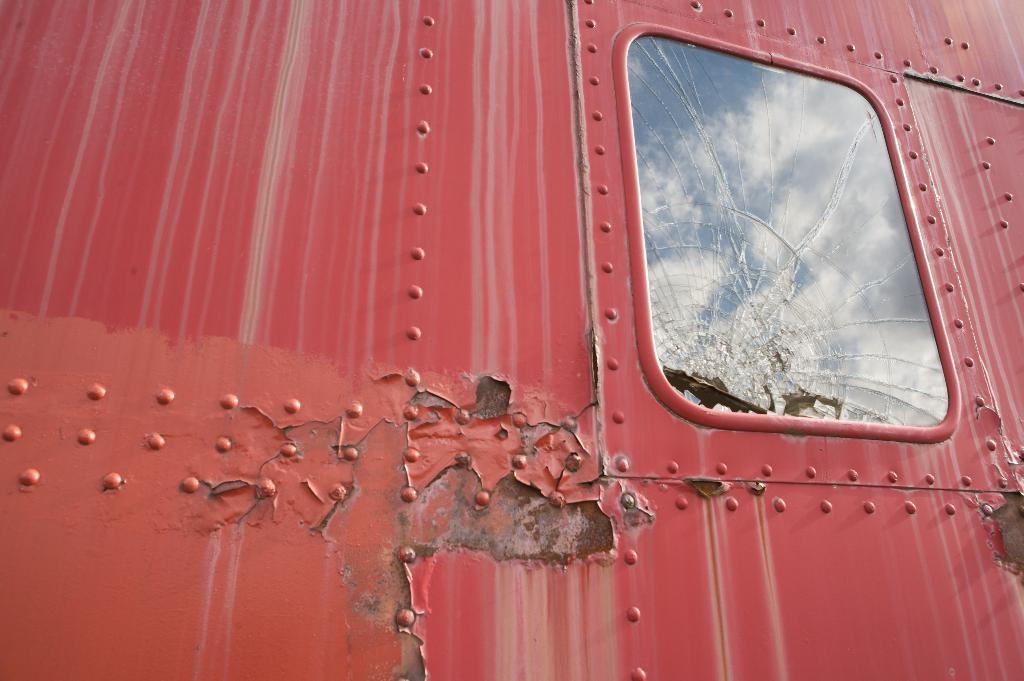What is the main subject of the image? The main subject of the image is a vehicle. Can you describe the condition of the vehicle? The vehicle has broken windows. Is there an airport visible in the image? No, there is no airport present in the image. Can you tell me how the skate is used in the image? There is no skate present in the image. 